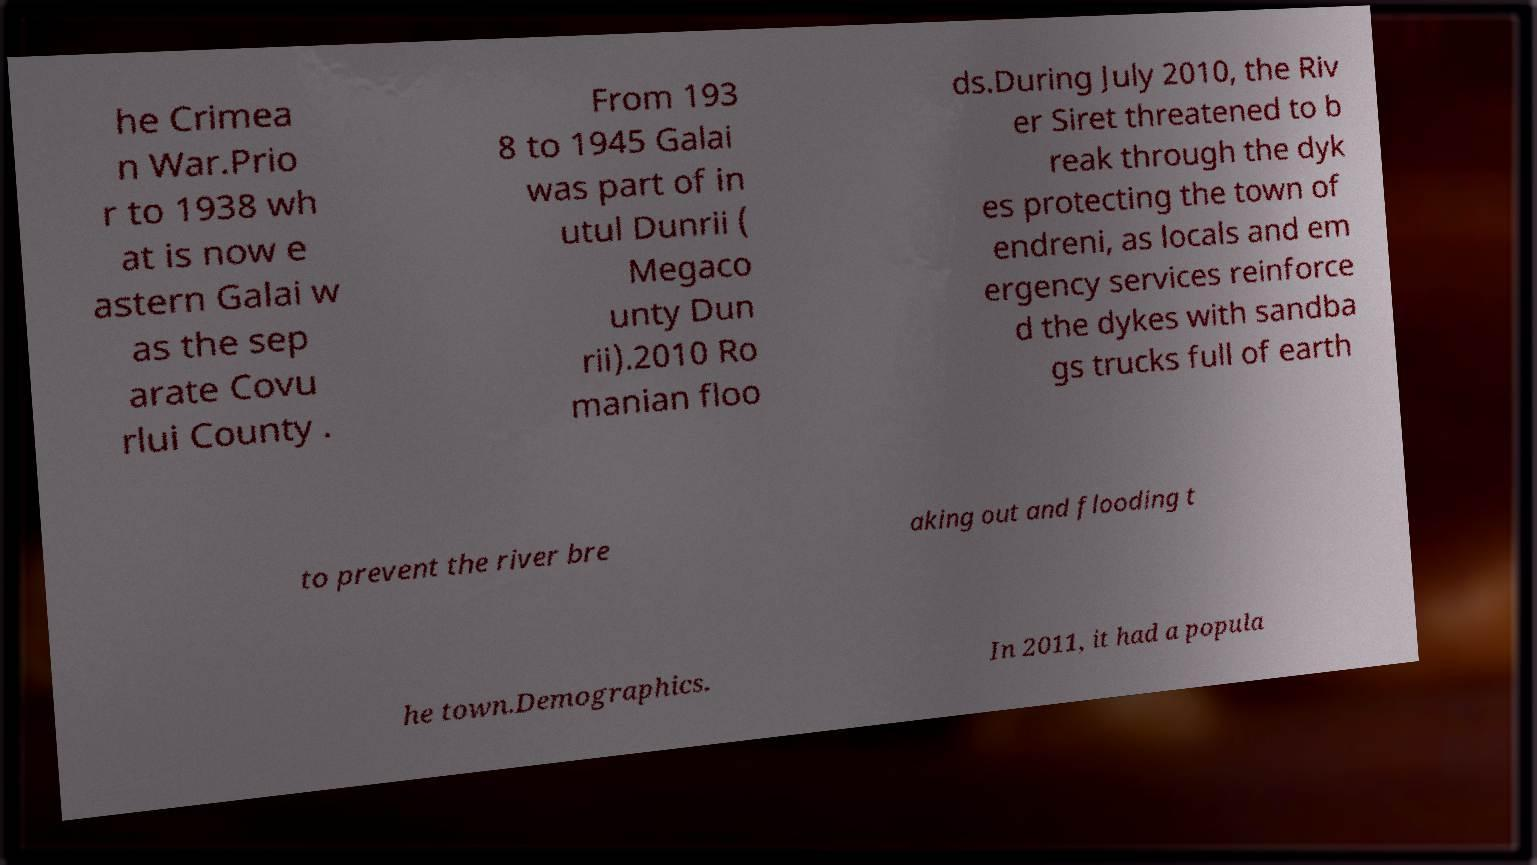What messages or text are displayed in this image? I need them in a readable, typed format. he Crimea n War.Prio r to 1938 wh at is now e astern Galai w as the sep arate Covu rlui County . From 193 8 to 1945 Galai was part of in utul Dunrii ( Megaco unty Dun rii).2010 Ro manian floo ds.During July 2010, the Riv er Siret threatened to b reak through the dyk es protecting the town of endreni, as locals and em ergency services reinforce d the dykes with sandba gs trucks full of earth to prevent the river bre aking out and flooding t he town.Demographics. In 2011, it had a popula 